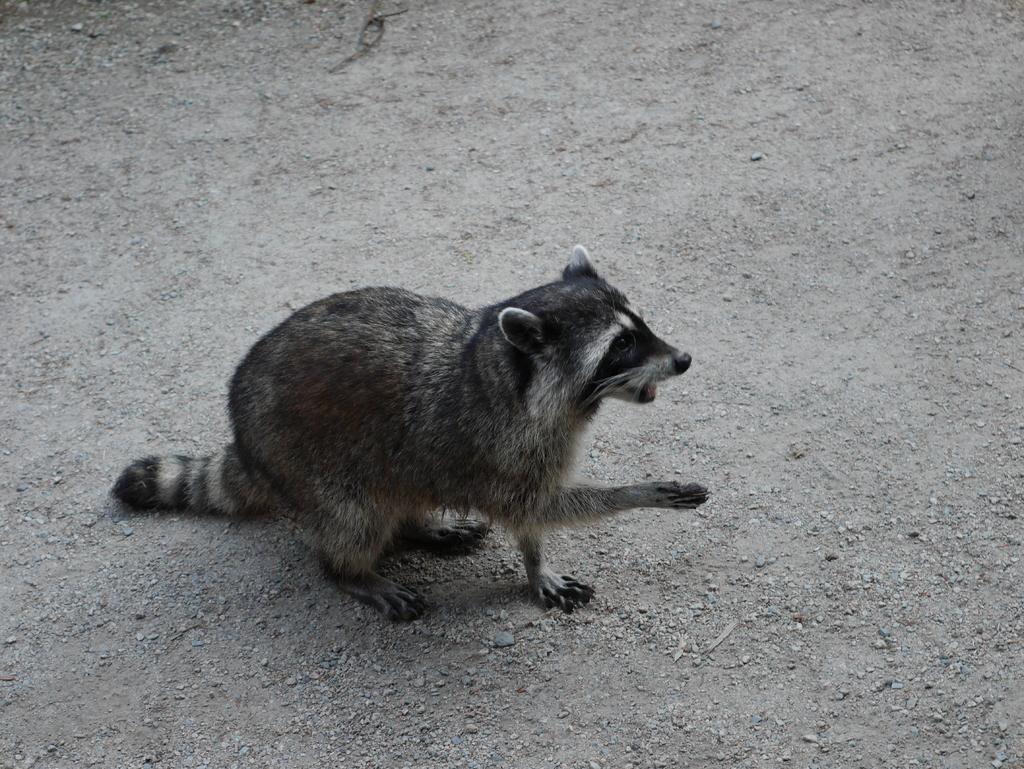What animal is present in the picture? There is a raccoon in the picture. What is the color of the raccoon? The raccoon is black in color. What type of surface is visible at the bottom of the picture? There are small stones at the bottom of the picture. What type of truck can be seen in the picture? There is no truck present in the picture; it features a black raccoon and small stones at the bottom. How does the raccoon's cough affect the stones in the picture? The raccoon does not exhibit any coughing in the picture, and the stones are not affected by any such action. 